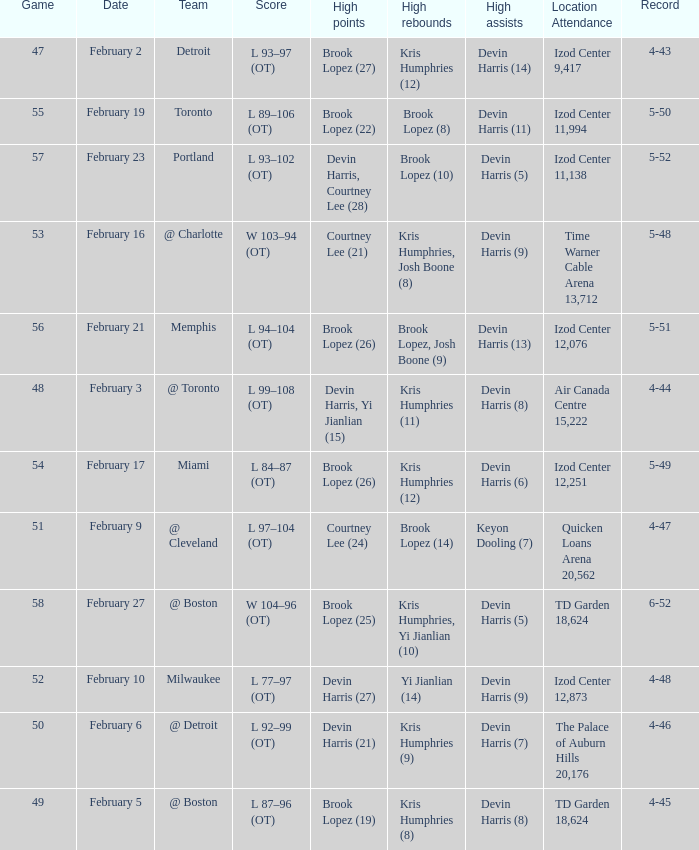What's the highest game number for a game in which Kris Humphries (8) did the high rebounds? 49.0. 